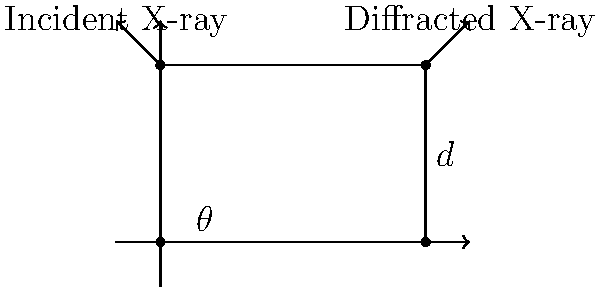In the early days of X-ray crystallography, we used Bragg's Law to determine the structure of crystals. Given the diagram of X-ray diffraction from crystal lattice planes, if the wavelength of the X-ray is 1.54 Å and the interplanar spacing (d) is 2.14 Å, what is the angle $\theta$ (in degrees) at which constructive interference occurs for the first-order diffraction (n=1)? To solve this problem, we'll use Bragg's Law and follow these steps:

1) Recall Bragg's Law: $n\lambda = 2d\sin\theta$

   Where:
   $n$ = order of diffraction (given as 1)
   $\lambda$ = wavelength of X-ray (given as 1.54 Å)
   $d$ = interplanar spacing (given as 2.14 Å)
   $\theta$ = angle of diffraction (what we need to find)

2) Substitute the known values into the equation:
   $1 \cdot 1.54 = 2 \cdot 2.14 \cdot \sin\theta$

3) Simplify:
   $1.54 = 4.28 \cdot \sin\theta$

4) Divide both sides by 4.28:
   $\frac{1.54}{4.28} = \sin\theta$

5) Calculate:
   $0.3598 = \sin\theta$

6) To find $\theta$, we need to take the inverse sine (arcsin) of both sides:
   $\theta = \arcsin(0.3598)$

7) Calculate (and convert to degrees):
   $\theta \approx 21.09°$

Thus, the angle at which constructive interference occurs is approximately 21.09°.
Answer: $21.09°$ 